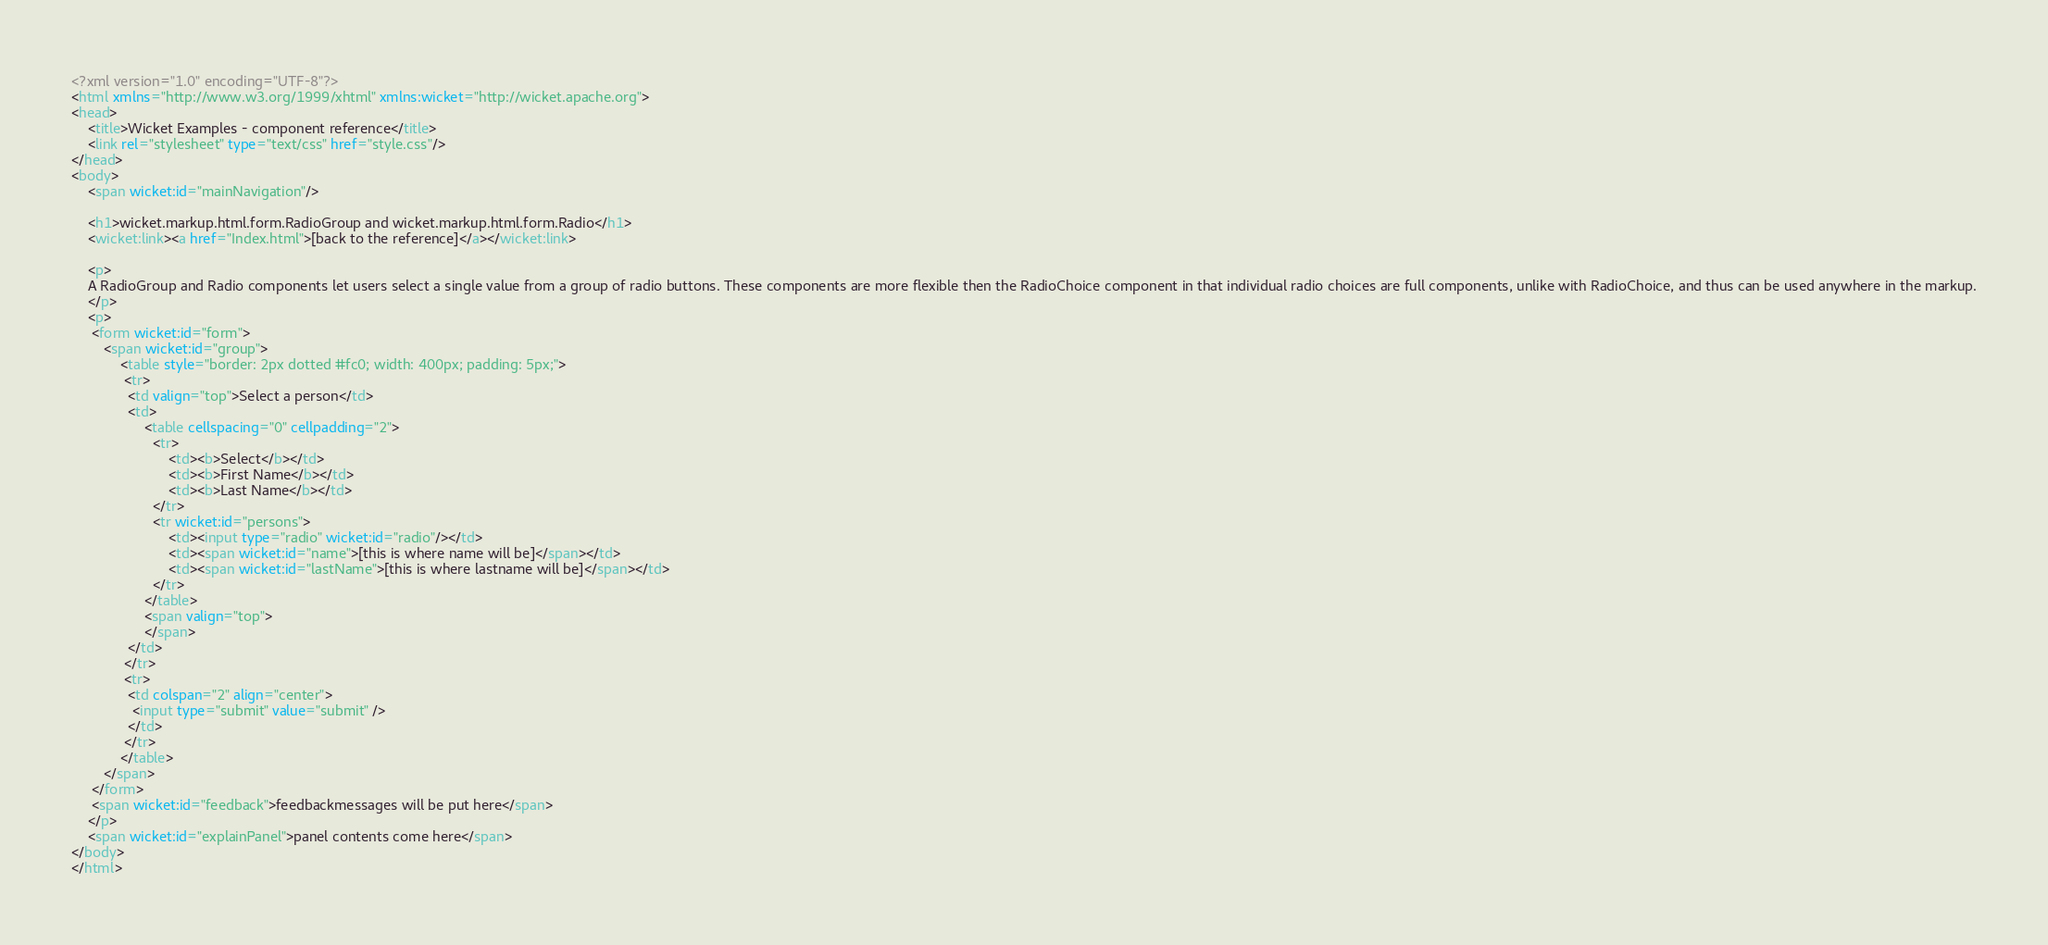Convert code to text. <code><loc_0><loc_0><loc_500><loc_500><_HTML_><?xml version="1.0" encoding="UTF-8"?>
<html xmlns="http://www.w3.org/1999/xhtml" xmlns:wicket="http://wicket.apache.org">
<head>
    <title>Wicket Examples - component reference</title>
    <link rel="stylesheet" type="text/css" href="style.css"/>
</head>
<body>
    <span wicket:id="mainNavigation"/>

	<h1>wicket.markup.html.form.RadioGroup and wicket.markup.html.form.Radio</h1>
	<wicket:link><a href="Index.html">[back to the reference]</a></wicket:link>

	<p>
	A RadioGroup and Radio components let users select a single value from a group of radio buttons. These components are more flexible then the RadioChoice component in that individual radio choices are full components, unlike with RadioChoice, and thus can be used anywhere in the markup.
	</p>
	<p>
	 <form wicket:id="form">
		<span wicket:id="group">
			<table style="border: 2px dotted #fc0; width: 400px; padding: 5px;">
			 <tr>
			  <td valign="top">Select a person</td>
			  <td>
				  <table cellspacing="0" cellpadding="2">
					<tr>
						<td><b>Select</b></td>
						<td><b>First Name</b></td>
						<td><b>Last Name</b></td>
					</tr>
				  	<tr wicket:id="persons">
				  		<td><input type="radio" wicket:id="radio"/></td>
				  		<td><span wicket:id="name">[this is where name will be]</span></td>
				  		<td><span wicket:id="lastName">[this is where lastname will be]</span></td>
				  	</tr>
				  </table>
				  <span valign="top">
				  </span>
			  </td>
			 </tr>
			 <tr>
			  <td colspan="2" align="center">
			   <input type="submit" value="submit" />
			  </td>
			 </tr>
			</table>
		</span>
	 </form>
	 <span wicket:id="feedback">feedbackmessages will be put here</span>
	</p>
    <span wicket:id="explainPanel">panel contents come here</span>
</body>
</html>
</code> 